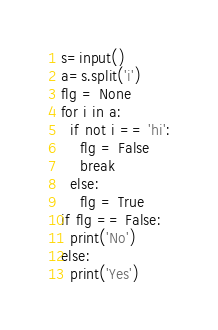<code> <loc_0><loc_0><loc_500><loc_500><_Python_>s=input()
a=s.split('i')
flg = None
for i in a:
  if not i == 'hi':
    flg = False
    break
  else:
    flg = True
if flg == False:
  print('No')
else:
  print('Yes')</code> 